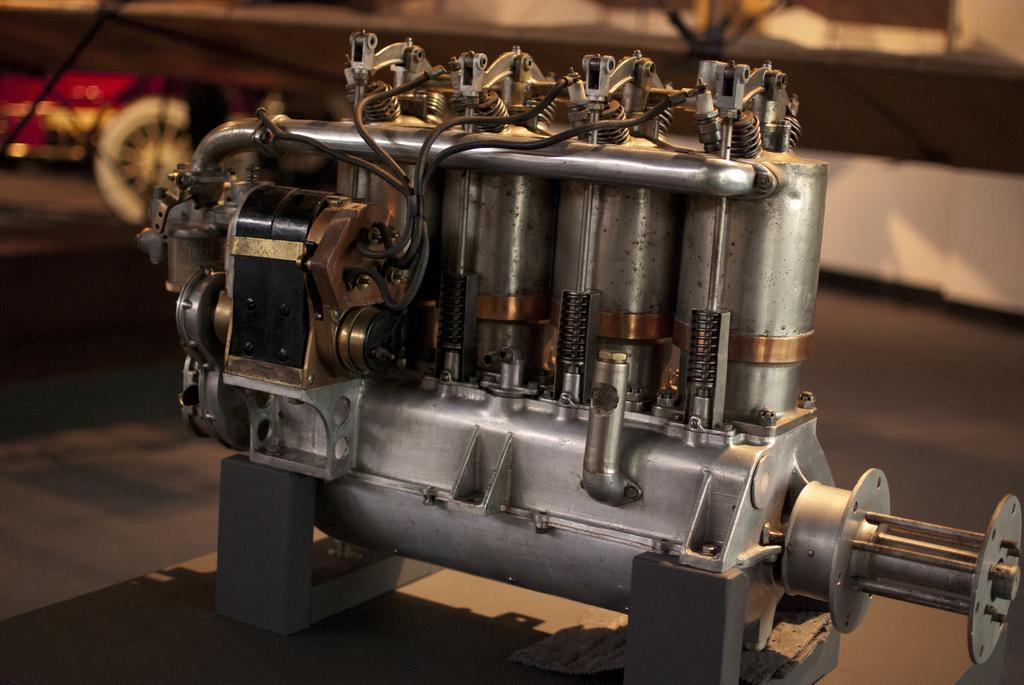What is the main object in the image? There is a machine in the image. Where is the machine located? The machine is on a table. What books does the mom use to mark important pages in the image? There is no mom or books present in the image; it only features a machine on a table. 